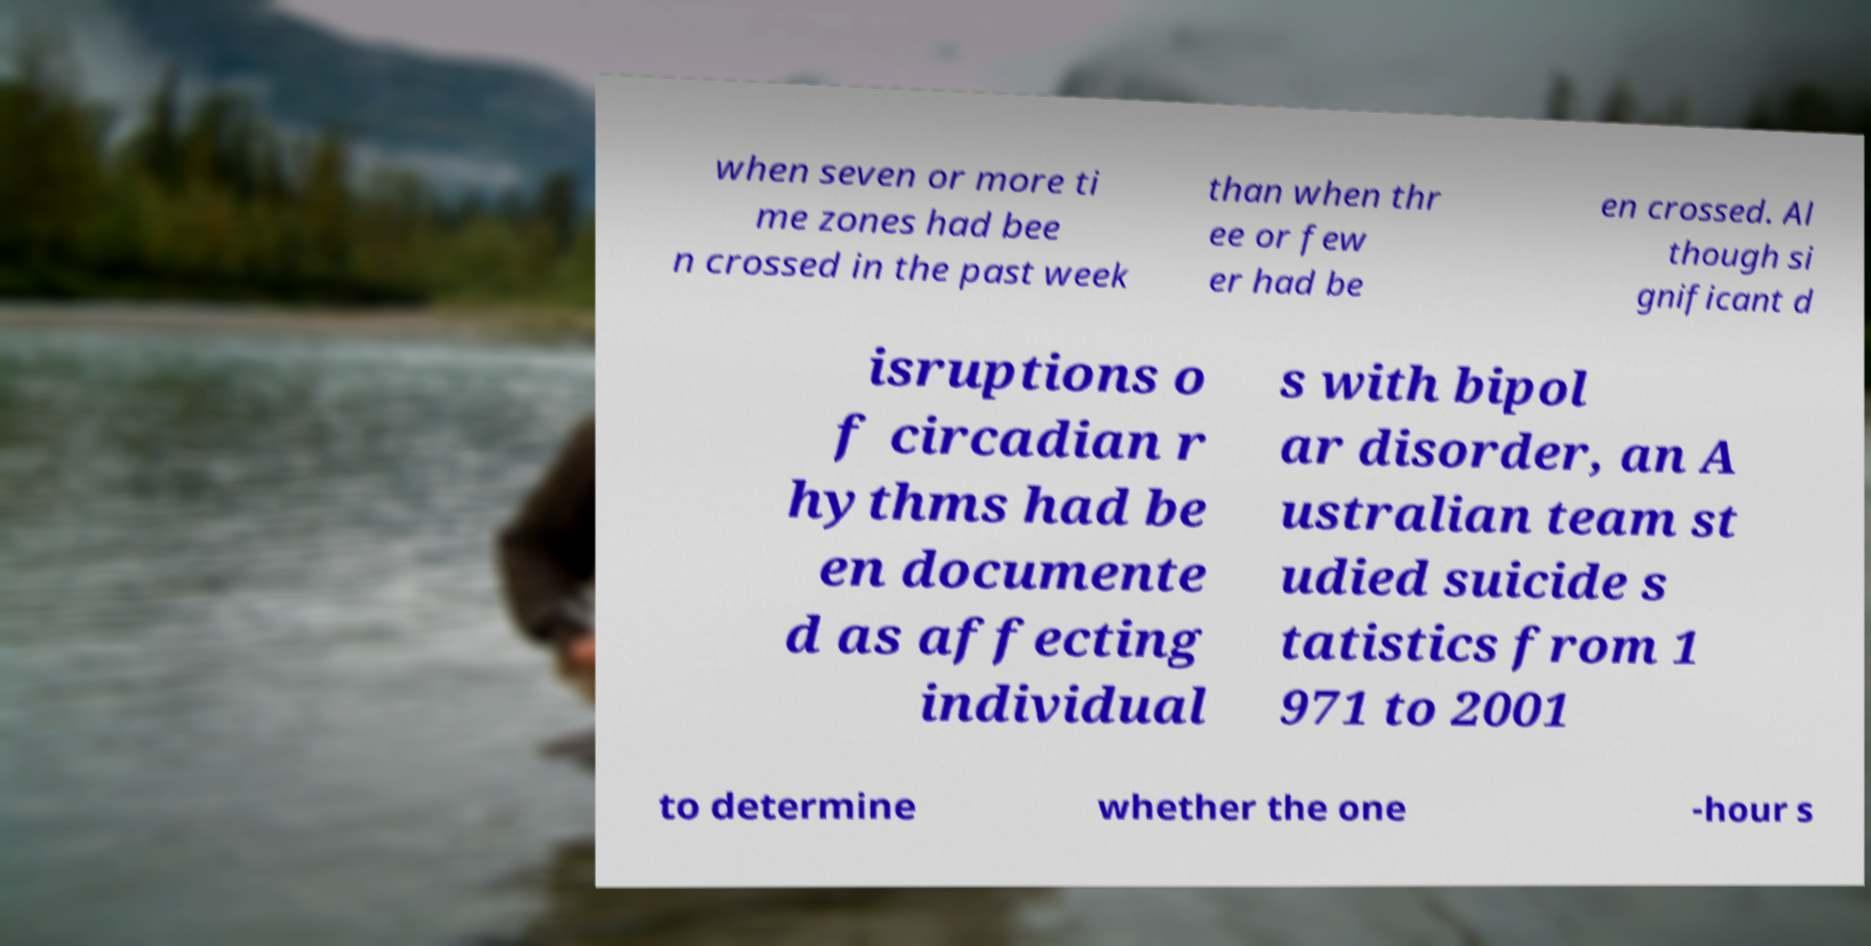Please identify and transcribe the text found in this image. when seven or more ti me zones had bee n crossed in the past week than when thr ee or few er had be en crossed. Al though si gnificant d isruptions o f circadian r hythms had be en documente d as affecting individual s with bipol ar disorder, an A ustralian team st udied suicide s tatistics from 1 971 to 2001 to determine whether the one -hour s 